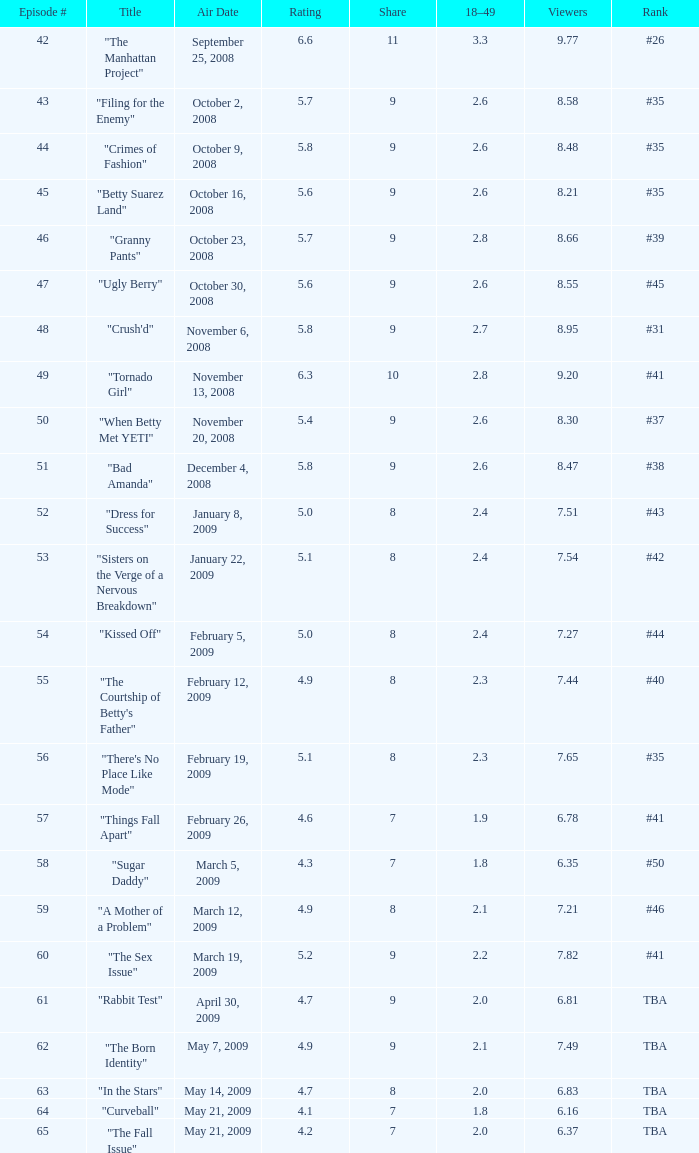What is the Air Date that has a 18–49 larger than 1.9, less than 7.54 viewers and a rating less than 4.9? April 30, 2009, May 14, 2009, May 21, 2009. 